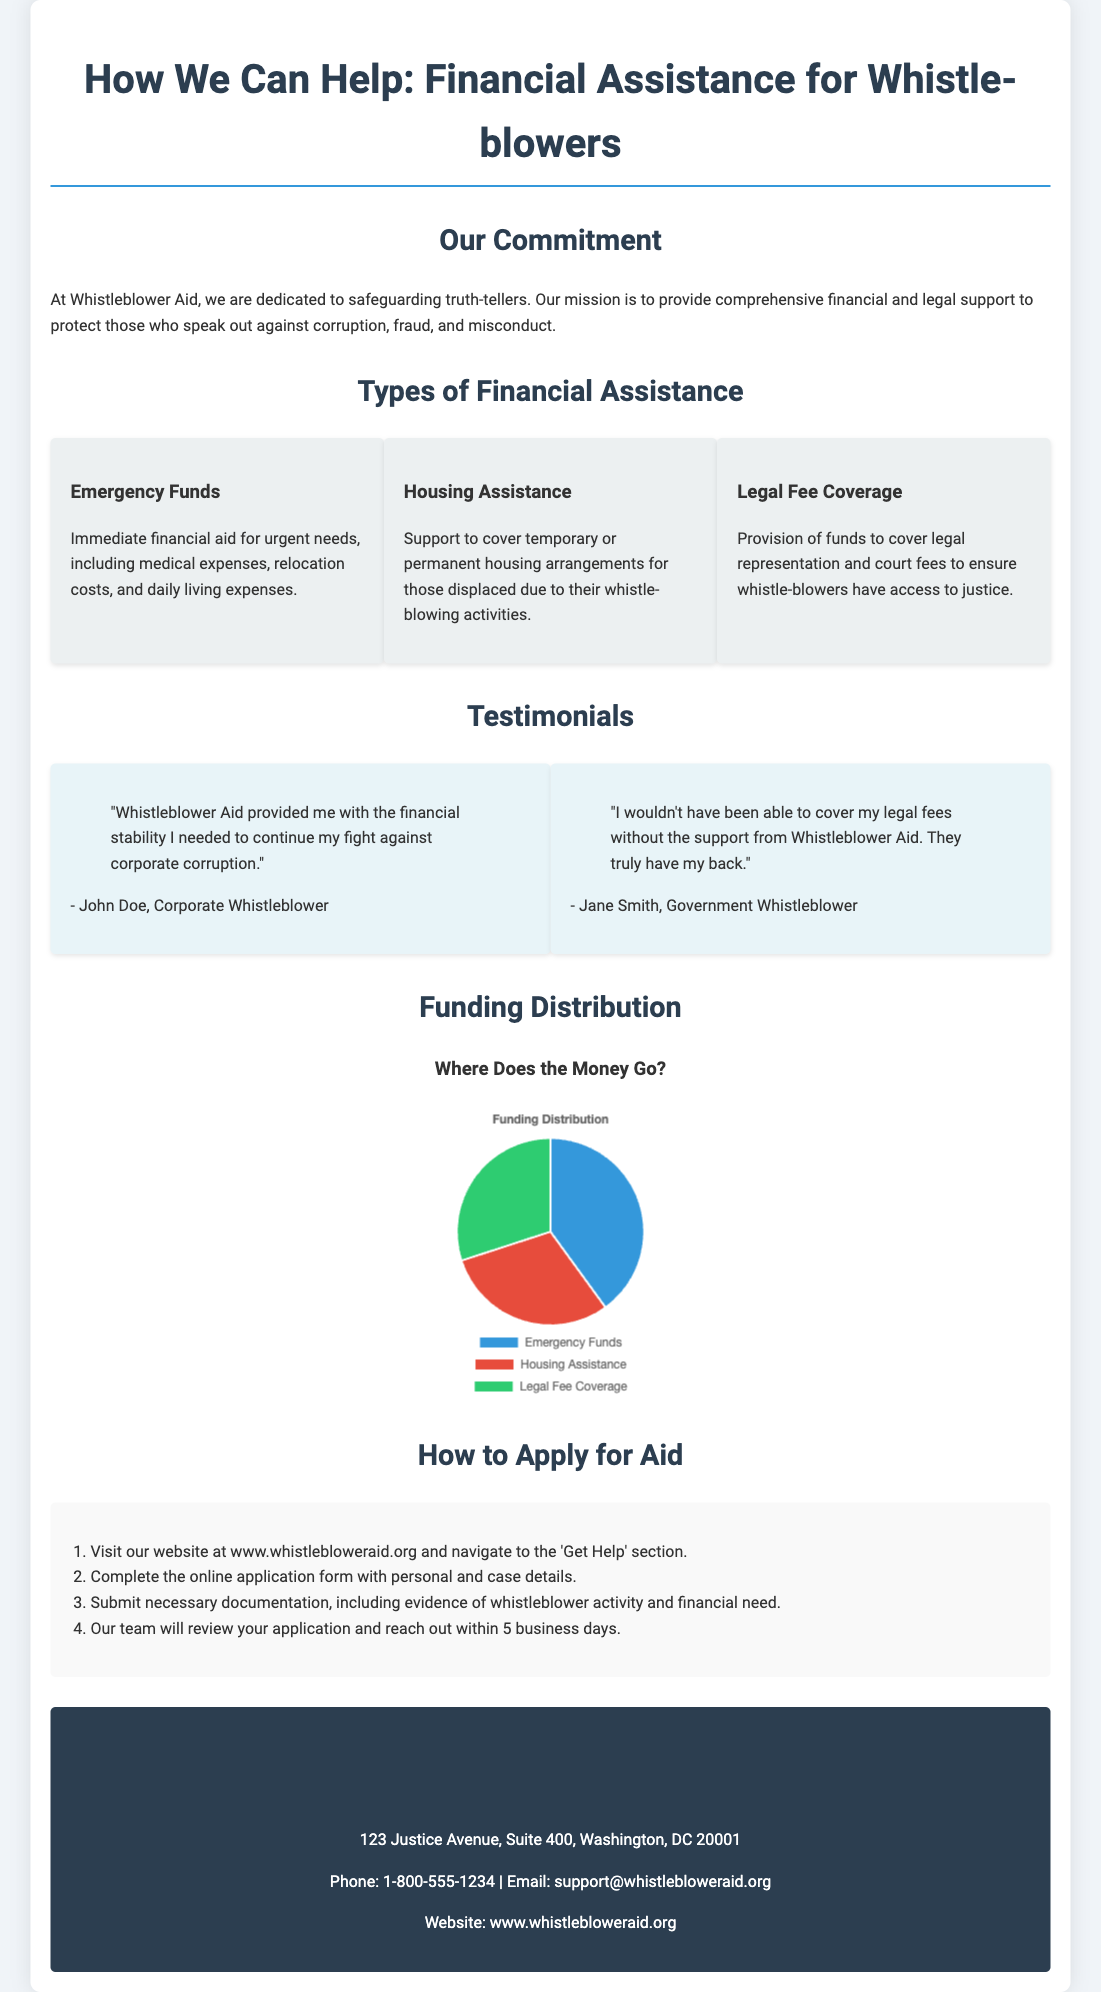What types of financial assistance do you offer? The document lists three types of financial assistance: Emergency Funds, Housing Assistance, and Legal Fee Coverage.
Answer: Emergency Funds, Housing Assistance, Legal Fee Coverage What is the primary purpose of your organization? The purpose of the organization is provided in the commitment section, emphasizing financial and legal support for whistle-blowers.
Answer: Safeguarding truth-tellers How long does it take to review an application? The document states that the team will reach out within 5 business days after reviewing the application.
Answer: 5 business days What is the address of your organization? The contact information section provides the address of the organization.
Answer: 123 Justice Avenue, Suite 400, Washington, DC 20001 What percentage of funding is allocated to Emergency Funds? The funding distribution chart shows that 40% of the funds are allocated for Emergency Funds.
Answer: 40% Who provided a testimonial about covering legal fees? The testimonial section includes a quote from Jane Smith regarding support for legal fees.
Answer: Jane Smith What is the title of the infographic in the funding distribution section? The infographic section has a title that explains the focus of the visual representation.
Answer: Where Does the Money Go? What should you visit to apply for aid? The document advises visiting a specific section of the organization's website to apply for assistance.
Answer: www.whistlebloweraid.org What kind of assistance is available for those displaced due to whistle-blowing activities? One of the types of financial assistance is specifically mentioned for those who are displaced.
Answer: Housing Assistance 